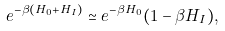<formula> <loc_0><loc_0><loc_500><loc_500>e ^ { - \beta ( H _ { 0 } + H _ { I } ) } \simeq e ^ { - \beta H _ { 0 } } ( 1 - \beta H _ { I } ) ,</formula> 